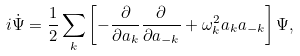<formula> <loc_0><loc_0><loc_500><loc_500>i \dot { \Psi } = \frac { 1 } { 2 } \sum _ { k } \left [ - \frac { \partial } { \partial a _ { k } } \frac { \partial } { \partial a _ { - k } } + \omega ^ { 2 } _ { k } a _ { k } a _ { - { k } } \right ] \Psi ,</formula> 